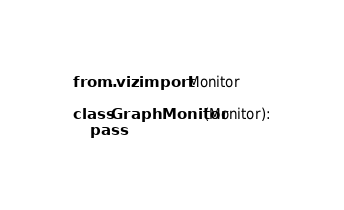Convert code to text. <code><loc_0><loc_0><loc_500><loc_500><_Python_>from ..viz import Monitor

class GraphMonitor(Monitor):
    pass</code> 